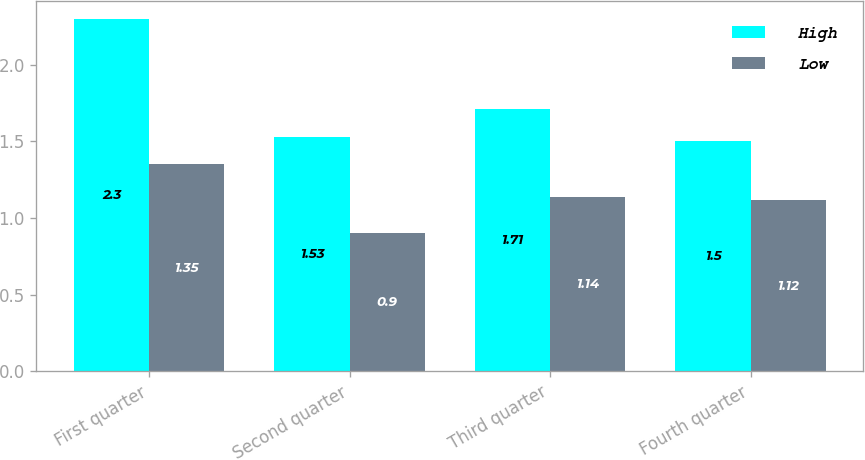Convert chart. <chart><loc_0><loc_0><loc_500><loc_500><stacked_bar_chart><ecel><fcel>First quarter<fcel>Second quarter<fcel>Third quarter<fcel>Fourth quarter<nl><fcel>High<fcel>2.3<fcel>1.53<fcel>1.71<fcel>1.5<nl><fcel>Low<fcel>1.35<fcel>0.9<fcel>1.14<fcel>1.12<nl></chart> 